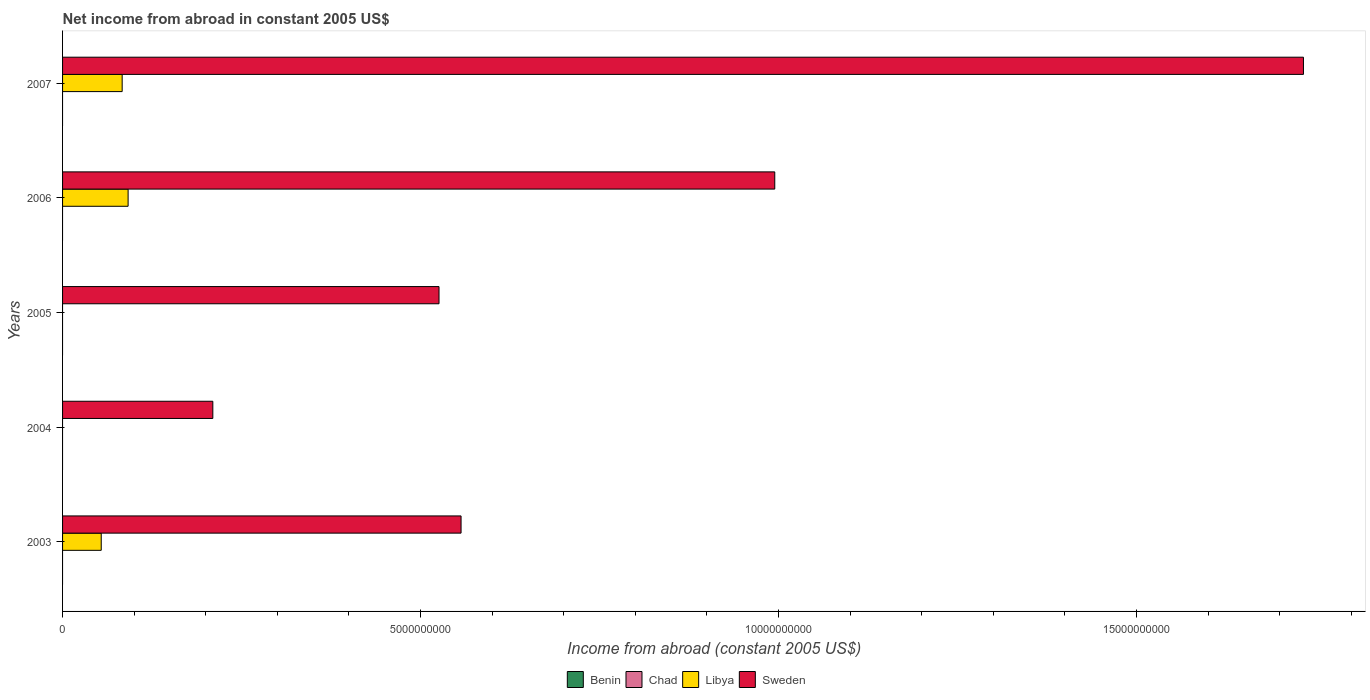Are the number of bars per tick equal to the number of legend labels?
Give a very brief answer. No. How many bars are there on the 5th tick from the top?
Ensure brevity in your answer.  2. Across all years, what is the maximum net income from abroad in Sweden?
Your response must be concise. 1.73e+1. What is the total net income from abroad in Libya in the graph?
Provide a short and direct response. 2.29e+09. What is the difference between the net income from abroad in Sweden in 2004 and that in 2006?
Offer a very short reply. -7.85e+09. What is the difference between the net income from abroad in Chad in 2006 and the net income from abroad in Sweden in 2005?
Ensure brevity in your answer.  -5.26e+09. What is the average net income from abroad in Libya per year?
Keep it short and to the point. 4.58e+08. In the year 2007, what is the difference between the net income from abroad in Sweden and net income from abroad in Libya?
Provide a short and direct response. 1.65e+1. In how many years, is the net income from abroad in Libya greater than 2000000000 US$?
Your response must be concise. 0. What is the ratio of the net income from abroad in Sweden in 2003 to that in 2004?
Your answer should be compact. 2.65. Is the difference between the net income from abroad in Sweden in 2003 and 2006 greater than the difference between the net income from abroad in Libya in 2003 and 2006?
Your answer should be very brief. No. What is the difference between the highest and the second highest net income from abroad in Sweden?
Ensure brevity in your answer.  7.38e+09. What is the difference between the highest and the lowest net income from abroad in Sweden?
Provide a short and direct response. 1.52e+1. Are all the bars in the graph horizontal?
Provide a short and direct response. Yes. How many years are there in the graph?
Give a very brief answer. 5. Does the graph contain any zero values?
Make the answer very short. Yes. Does the graph contain grids?
Your answer should be very brief. No. Where does the legend appear in the graph?
Offer a terse response. Bottom center. How are the legend labels stacked?
Provide a succinct answer. Horizontal. What is the title of the graph?
Your answer should be compact. Net income from abroad in constant 2005 US$. What is the label or title of the X-axis?
Provide a succinct answer. Income from abroad (constant 2005 US$). What is the Income from abroad (constant 2005 US$) of Libya in 2003?
Give a very brief answer. 5.40e+08. What is the Income from abroad (constant 2005 US$) in Sweden in 2003?
Offer a very short reply. 5.57e+09. What is the Income from abroad (constant 2005 US$) of Benin in 2004?
Give a very brief answer. 0. What is the Income from abroad (constant 2005 US$) in Chad in 2004?
Your response must be concise. 0. What is the Income from abroad (constant 2005 US$) in Libya in 2004?
Provide a succinct answer. 0. What is the Income from abroad (constant 2005 US$) of Sweden in 2004?
Provide a succinct answer. 2.10e+09. What is the Income from abroad (constant 2005 US$) in Libya in 2005?
Your response must be concise. 0. What is the Income from abroad (constant 2005 US$) in Sweden in 2005?
Offer a very short reply. 5.26e+09. What is the Income from abroad (constant 2005 US$) in Libya in 2006?
Give a very brief answer. 9.15e+08. What is the Income from abroad (constant 2005 US$) in Sweden in 2006?
Offer a very short reply. 9.95e+09. What is the Income from abroad (constant 2005 US$) of Libya in 2007?
Provide a short and direct response. 8.32e+08. What is the Income from abroad (constant 2005 US$) of Sweden in 2007?
Make the answer very short. 1.73e+1. Across all years, what is the maximum Income from abroad (constant 2005 US$) of Libya?
Your response must be concise. 9.15e+08. Across all years, what is the maximum Income from abroad (constant 2005 US$) in Sweden?
Give a very brief answer. 1.73e+1. Across all years, what is the minimum Income from abroad (constant 2005 US$) in Libya?
Provide a short and direct response. 0. Across all years, what is the minimum Income from abroad (constant 2005 US$) in Sweden?
Make the answer very short. 2.10e+09. What is the total Income from abroad (constant 2005 US$) in Benin in the graph?
Your answer should be very brief. 0. What is the total Income from abroad (constant 2005 US$) of Libya in the graph?
Offer a very short reply. 2.29e+09. What is the total Income from abroad (constant 2005 US$) of Sweden in the graph?
Your answer should be very brief. 4.02e+1. What is the difference between the Income from abroad (constant 2005 US$) in Sweden in 2003 and that in 2004?
Offer a very short reply. 3.47e+09. What is the difference between the Income from abroad (constant 2005 US$) in Sweden in 2003 and that in 2005?
Offer a terse response. 3.08e+08. What is the difference between the Income from abroad (constant 2005 US$) in Libya in 2003 and that in 2006?
Keep it short and to the point. -3.75e+08. What is the difference between the Income from abroad (constant 2005 US$) of Sweden in 2003 and that in 2006?
Offer a very short reply. -4.38e+09. What is the difference between the Income from abroad (constant 2005 US$) in Libya in 2003 and that in 2007?
Make the answer very short. -2.92e+08. What is the difference between the Income from abroad (constant 2005 US$) of Sweden in 2003 and that in 2007?
Provide a short and direct response. -1.18e+1. What is the difference between the Income from abroad (constant 2005 US$) of Sweden in 2004 and that in 2005?
Provide a succinct answer. -3.16e+09. What is the difference between the Income from abroad (constant 2005 US$) of Sweden in 2004 and that in 2006?
Offer a very short reply. -7.85e+09. What is the difference between the Income from abroad (constant 2005 US$) in Sweden in 2004 and that in 2007?
Provide a short and direct response. -1.52e+1. What is the difference between the Income from abroad (constant 2005 US$) of Sweden in 2005 and that in 2006?
Keep it short and to the point. -4.69e+09. What is the difference between the Income from abroad (constant 2005 US$) in Sweden in 2005 and that in 2007?
Offer a very short reply. -1.21e+1. What is the difference between the Income from abroad (constant 2005 US$) in Libya in 2006 and that in 2007?
Make the answer very short. 8.30e+07. What is the difference between the Income from abroad (constant 2005 US$) of Sweden in 2006 and that in 2007?
Your answer should be compact. -7.38e+09. What is the difference between the Income from abroad (constant 2005 US$) of Libya in 2003 and the Income from abroad (constant 2005 US$) of Sweden in 2004?
Keep it short and to the point. -1.56e+09. What is the difference between the Income from abroad (constant 2005 US$) of Libya in 2003 and the Income from abroad (constant 2005 US$) of Sweden in 2005?
Your answer should be compact. -4.72e+09. What is the difference between the Income from abroad (constant 2005 US$) in Libya in 2003 and the Income from abroad (constant 2005 US$) in Sweden in 2006?
Your answer should be very brief. -9.41e+09. What is the difference between the Income from abroad (constant 2005 US$) in Libya in 2003 and the Income from abroad (constant 2005 US$) in Sweden in 2007?
Your response must be concise. -1.68e+1. What is the difference between the Income from abroad (constant 2005 US$) in Libya in 2006 and the Income from abroad (constant 2005 US$) in Sweden in 2007?
Your answer should be compact. -1.64e+1. What is the average Income from abroad (constant 2005 US$) of Benin per year?
Keep it short and to the point. 0. What is the average Income from abroad (constant 2005 US$) in Chad per year?
Keep it short and to the point. 0. What is the average Income from abroad (constant 2005 US$) in Libya per year?
Your response must be concise. 4.58e+08. What is the average Income from abroad (constant 2005 US$) in Sweden per year?
Your answer should be very brief. 8.04e+09. In the year 2003, what is the difference between the Income from abroad (constant 2005 US$) in Libya and Income from abroad (constant 2005 US$) in Sweden?
Your answer should be compact. -5.03e+09. In the year 2006, what is the difference between the Income from abroad (constant 2005 US$) of Libya and Income from abroad (constant 2005 US$) of Sweden?
Offer a terse response. -9.03e+09. In the year 2007, what is the difference between the Income from abroad (constant 2005 US$) in Libya and Income from abroad (constant 2005 US$) in Sweden?
Provide a short and direct response. -1.65e+1. What is the ratio of the Income from abroad (constant 2005 US$) in Sweden in 2003 to that in 2004?
Keep it short and to the point. 2.65. What is the ratio of the Income from abroad (constant 2005 US$) in Sweden in 2003 to that in 2005?
Ensure brevity in your answer.  1.06. What is the ratio of the Income from abroad (constant 2005 US$) in Libya in 2003 to that in 2006?
Offer a very short reply. 0.59. What is the ratio of the Income from abroad (constant 2005 US$) in Sweden in 2003 to that in 2006?
Offer a terse response. 0.56. What is the ratio of the Income from abroad (constant 2005 US$) of Libya in 2003 to that in 2007?
Your response must be concise. 0.65. What is the ratio of the Income from abroad (constant 2005 US$) of Sweden in 2003 to that in 2007?
Your answer should be very brief. 0.32. What is the ratio of the Income from abroad (constant 2005 US$) of Sweden in 2004 to that in 2005?
Offer a very short reply. 0.4. What is the ratio of the Income from abroad (constant 2005 US$) of Sweden in 2004 to that in 2006?
Your answer should be very brief. 0.21. What is the ratio of the Income from abroad (constant 2005 US$) in Sweden in 2004 to that in 2007?
Keep it short and to the point. 0.12. What is the ratio of the Income from abroad (constant 2005 US$) of Sweden in 2005 to that in 2006?
Provide a short and direct response. 0.53. What is the ratio of the Income from abroad (constant 2005 US$) of Sweden in 2005 to that in 2007?
Ensure brevity in your answer.  0.3. What is the ratio of the Income from abroad (constant 2005 US$) of Libya in 2006 to that in 2007?
Provide a short and direct response. 1.1. What is the ratio of the Income from abroad (constant 2005 US$) of Sweden in 2006 to that in 2007?
Keep it short and to the point. 0.57. What is the difference between the highest and the second highest Income from abroad (constant 2005 US$) in Libya?
Your response must be concise. 8.30e+07. What is the difference between the highest and the second highest Income from abroad (constant 2005 US$) of Sweden?
Keep it short and to the point. 7.38e+09. What is the difference between the highest and the lowest Income from abroad (constant 2005 US$) in Libya?
Offer a terse response. 9.15e+08. What is the difference between the highest and the lowest Income from abroad (constant 2005 US$) in Sweden?
Make the answer very short. 1.52e+1. 